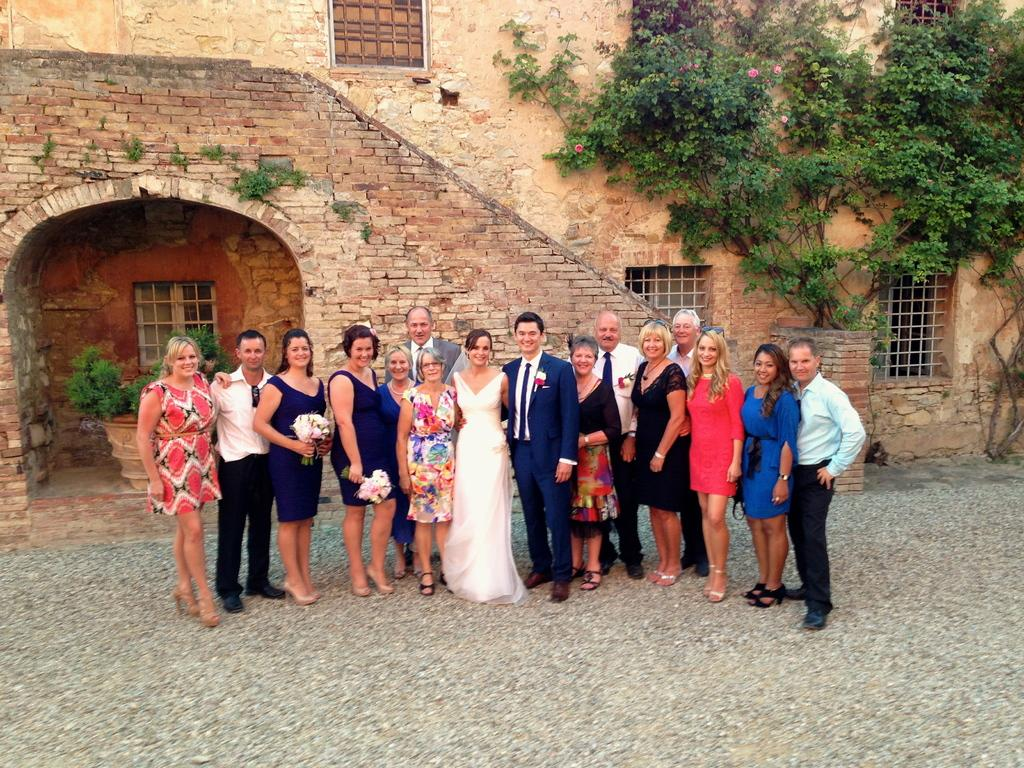What is happening in the image involving the group of people? The people in the image are standing and smiling. Are there any specific objects being held by the people? Yes, two persons are holding bouquets. What can be seen in the background of the image? There are plants and a building in the background of the image. Can you tell me how many jars are visible on the person's head in the image? There are no jars visible on anyone's head in the image. What type of beast is interacting with the people in the image? There is no beast present in the image; it features a group of people standing and smiling. 